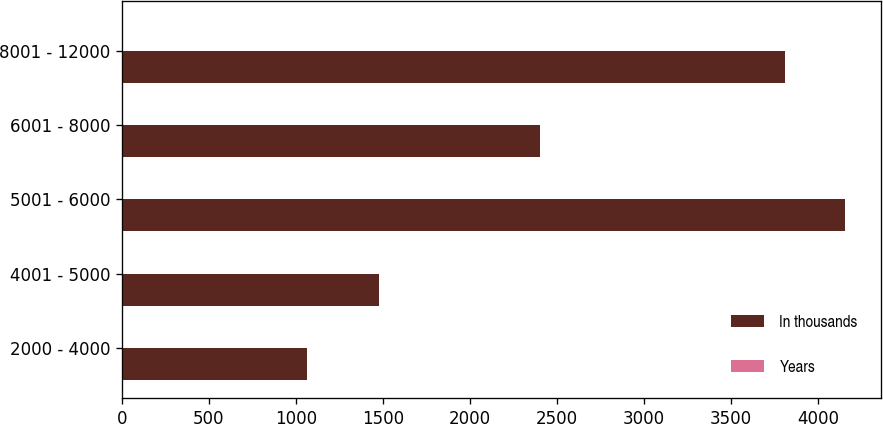<chart> <loc_0><loc_0><loc_500><loc_500><stacked_bar_chart><ecel><fcel>2000 - 4000<fcel>4001 - 5000<fcel>5001 - 6000<fcel>6001 - 8000<fcel>8001 - 12000<nl><fcel>In thousands<fcel>1065<fcel>1477<fcel>4153<fcel>2400<fcel>3808<nl><fcel>Years<fcel>2<fcel>3<fcel>5<fcel>7<fcel>7<nl></chart> 